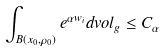<formula> <loc_0><loc_0><loc_500><loc_500>\int _ { B ( x _ { 0 } , \rho _ { 0 } ) } e ^ { \alpha w _ { i } } d v o l _ { g } \leq C _ { \alpha }</formula> 